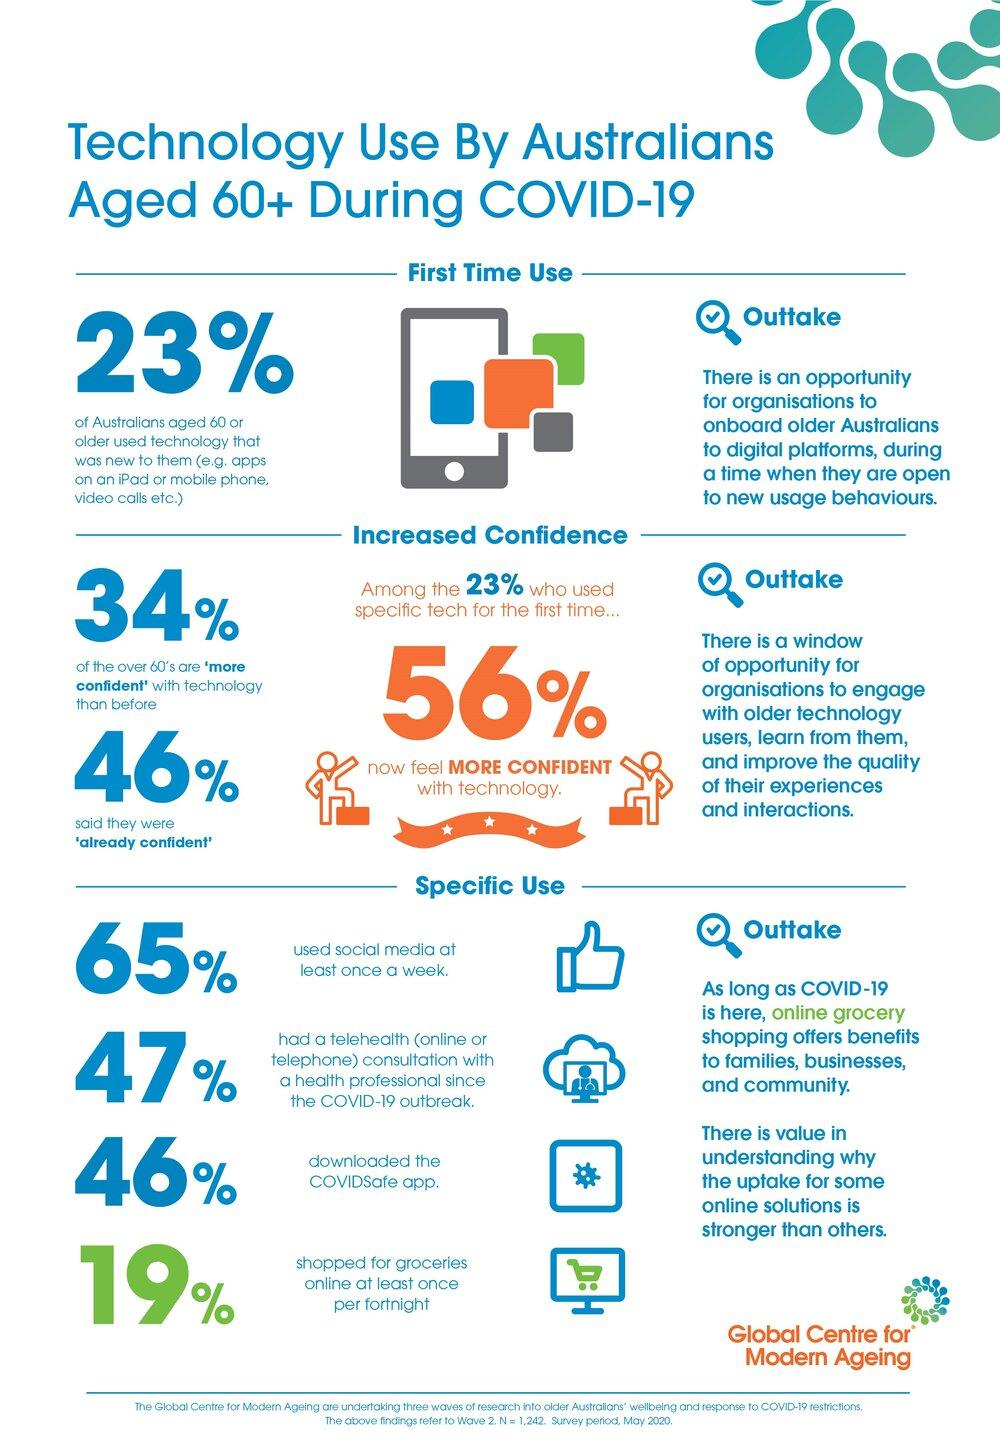Identify some key points in this picture. According to the survey, 65% of the participants used Instagram, Facebook, or Twitter at least once during the week. According to the data, 19% of senior citizens reported shopping for groceries at least once in a two-week period. A significant proportion of individuals over the age of 60 are less confident with technology, with 66% reporting a lack of confidence. According to recent data, 23% of senior citizens are using newer technology. 